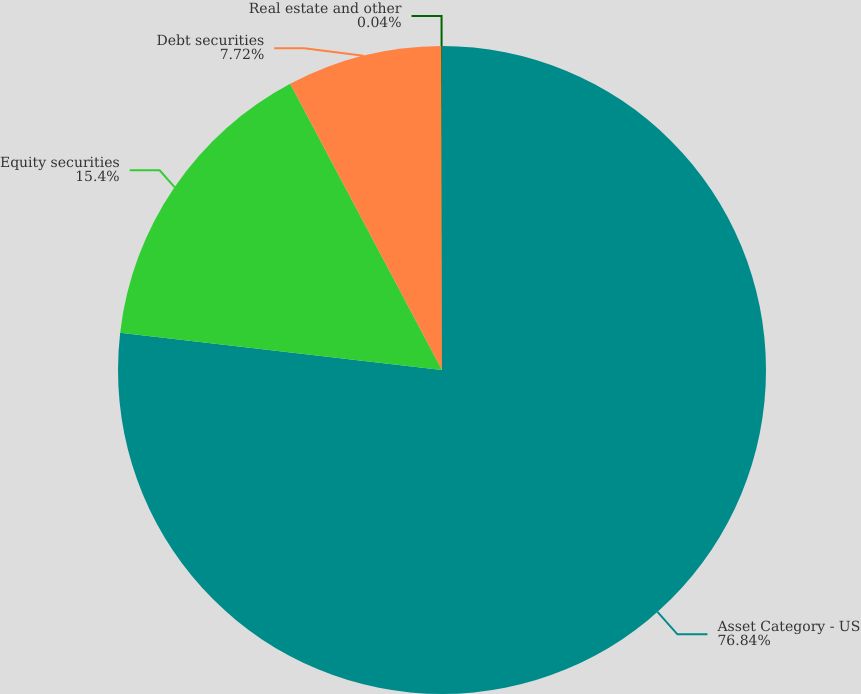<chart> <loc_0><loc_0><loc_500><loc_500><pie_chart><fcel>Asset Category - US<fcel>Equity securities<fcel>Debt securities<fcel>Real estate and other<nl><fcel>76.84%<fcel>15.4%<fcel>7.72%<fcel>0.04%<nl></chart> 